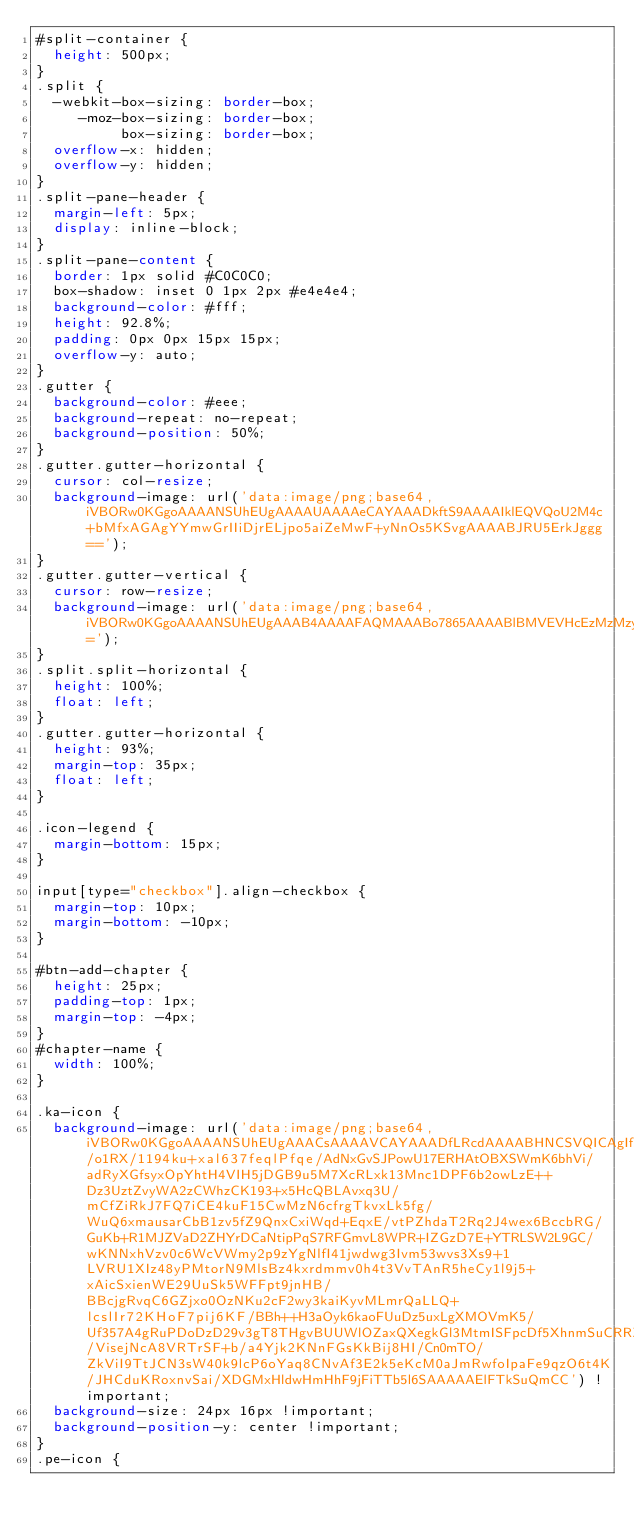Convert code to text. <code><loc_0><loc_0><loc_500><loc_500><_CSS_>#split-container {
  height: 500px;
}
.split {
  -webkit-box-sizing: border-box;
     -moz-box-sizing: border-box;
          box-sizing: border-box;
  overflow-x: hidden;
  overflow-y: hidden;
}
.split-pane-header {
  margin-left: 5px;
  display: inline-block;
}
.split-pane-content {
  border: 1px solid #C0C0C0;
  box-shadow: inset 0 1px 2px #e4e4e4;
  background-color: #fff;
  height: 92.8%;
  padding: 0px 0px 15px 15px;
  overflow-y: auto;
}
.gutter {
  background-color: #eee;
  background-repeat: no-repeat;
  background-position: 50%;
}
.gutter.gutter-horizontal {
  cursor: col-resize;
  background-image: url('data:image/png;base64,iVBORw0KGgoAAAANSUhEUgAAAAUAAAAeCAYAAADkftS9AAAAIklEQVQoU2M4c+bMfxAGAgYYmwGrIIiDjrELjpo5aiZeMwF+yNnOs5KSvgAAAABJRU5ErkJggg==');
}
.gutter.gutter-vertical {
  cursor: row-resize;
  background-image: url('data:image/png;base64,iVBORw0KGgoAAAANSUhEUgAAAB4AAAAFAQMAAABo7865AAAABlBMVEVHcEzMzMzyAv2sAAAAAXRSTlMAQObYZgAAABBJREFUeF5jOAMEEAIEEFwAn3kMwcB6I2AAAAAASUVORK5CYII=');
}
.split.split-horizontal {
  height: 100%;
  float: left;
}
.gutter.gutter-horizontal {
  height: 93%;
  margin-top: 35px;
  float: left;
}

.icon-legend {
  margin-bottom: 15px;
}

input[type="checkbox"].align-checkbox {
  margin-top: 10px;
  margin-bottom: -10px;
}

#btn-add-chapter {
  height: 25px;
  padding-top: 1px;
  margin-top: -4px;
}
#chapter-name {
  width: 100%;
}

.ka-icon {
  background-image: url('data:image/png;base64,iVBORw0KGgoAAAANSUhEUgAAACsAAAAVCAYAAADfLRcdAAAABHNCSVQICAgIfAhkiAAAAodJREFUSImt10uMjUkYBuDHabemBXELIUaGaWIjbrOwIBghs5mVSyzEQiwkJixsiBAbHWIhIhKzIRYWNoiIWFkgsSCdMCZBMq5jxm3h1tpwLP6/o1RX/1194ku+xal637feqlPfqe/AdNxGvSJPowU17ERHAtOBXSWmK6bhVi/adRyXGfsyxOpYhtH4VIH5jDGB9u5M7XcRLxk13Mnc1DPF6b2owLzE++Dz3UztZvyWA2zCWhzCK193+x5HcQBLAvxq3U/mCfZiRkJ7FQ7iCE4kuF15CwMzN6cfrgTkvxLk5fg/WuQ6xmausarCbB1zv5fZ9QnxCxiWqd+EqxE/vtPZhdaT2Rq2J4wex6BccbRG/GuKb+R1MJZVaD2ZHYrDCaNtipPqS7RFGmvL8WPR+IZGzD7E+YTRLSW2L9GC/wKNNxhVzv0c6WcVWmy2p9zYgNlfI41jwdwg3Ivm53wvs3Xs9+1LVRU1XIz48yPMtorN9MlsBz4kxrdmmv0h4t3VvTAnR5heCy1l9j5+xAicSxienWE29UuSk5WFFpt9jnHB/BBcjgRvqC6GZjxo0OzNKu2cF2wy3kaiKyvMLmrQaLLQ+lcslIr72KHoF7pij6KF/BBh++H3aOyk6kaoFUuDz5uxLgXMOVmK5/Uf357A4gRuPDoDzD29v3gT8THgvBUUWlOZaxQXegkGl3MtmISFpcDf5XhnmSuCRRZgJuYpns/VisejNcA8VRTrSF+b/a4Yjk2KNnFGsKkBij8HI/Cn0mTO/ZkViI9TtJCN3sW40k9lcP6oYaq8CNvAf3E2k5eKcM0aJmRwfoIpaFe9qzO6t4K/JHCduKRoxnvSai/XDGMxHldwHmHhF9jFiTTb5l6SAAAAAElFTkSuQmCC') !important;
  background-size: 24px 16px !important;
  background-position-y: center !important;
}
.pe-icon {</code> 